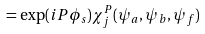Convert formula to latex. <formula><loc_0><loc_0><loc_500><loc_500>= \exp ( i P \phi _ { s } ) \chi _ { j } ^ { P } ( \psi _ { a } , \psi _ { b } , \psi _ { f } )</formula> 